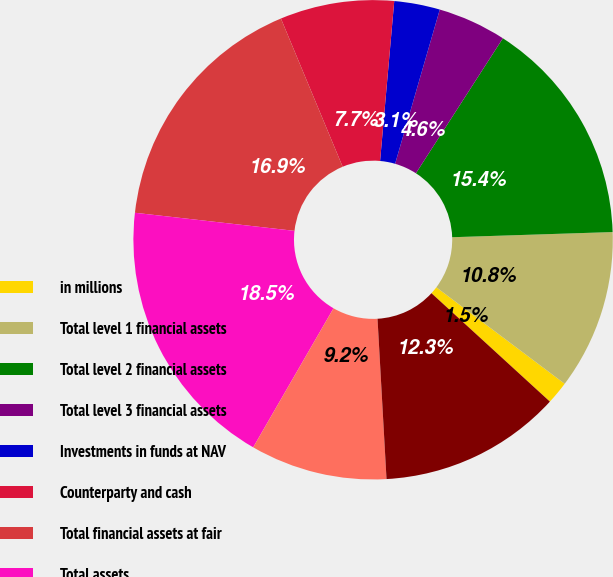<chart> <loc_0><loc_0><loc_500><loc_500><pie_chart><fcel>in millions<fcel>Total level 1 financial assets<fcel>Total level 2 financial assets<fcel>Total level 3 financial assets<fcel>Investments in funds at NAV<fcel>Counterparty and cash<fcel>Total financial assets at fair<fcel>Total assets<fcel>Total level 1 financial<fcel>Total level 2 financial<nl><fcel>1.54%<fcel>10.77%<fcel>15.38%<fcel>4.62%<fcel>3.08%<fcel>7.69%<fcel>16.92%<fcel>18.46%<fcel>9.23%<fcel>12.31%<nl></chart> 